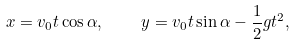Convert formula to latex. <formula><loc_0><loc_0><loc_500><loc_500>x = v _ { 0 } t \cos \alpha , \quad y = v _ { 0 } t \sin \alpha - \frac { 1 } { 2 } g t ^ { 2 } ,</formula> 